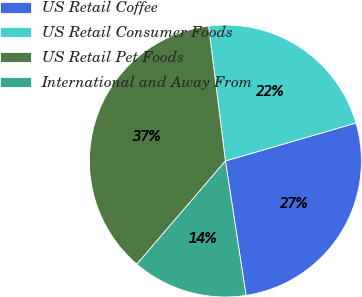<chart> <loc_0><loc_0><loc_500><loc_500><pie_chart><fcel>US Retail Coffee<fcel>US Retail Consumer Foods<fcel>US Retail Pet Foods<fcel>International and Away From<nl><fcel>27.08%<fcel>22.47%<fcel>36.74%<fcel>13.71%<nl></chart> 